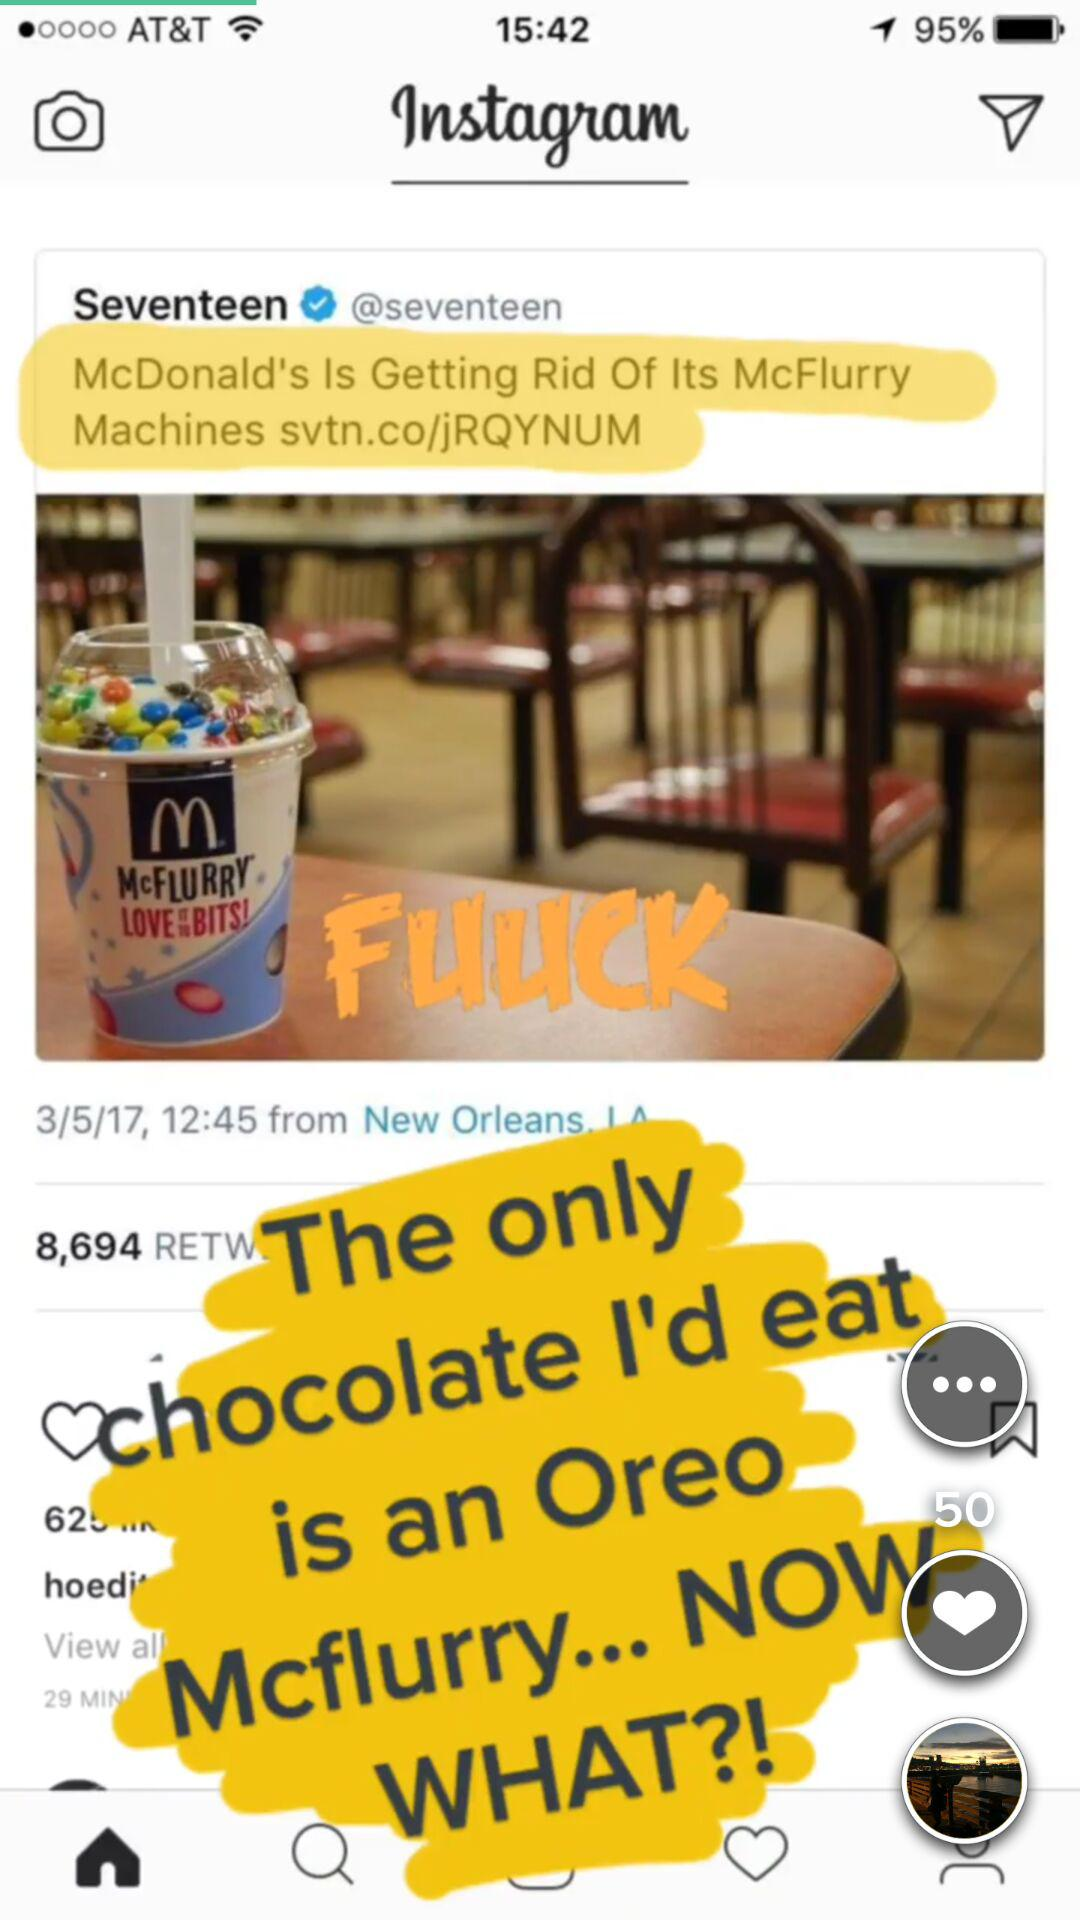How many minutes ago was the post published?
Answer the question using a single word or phrase. 29 